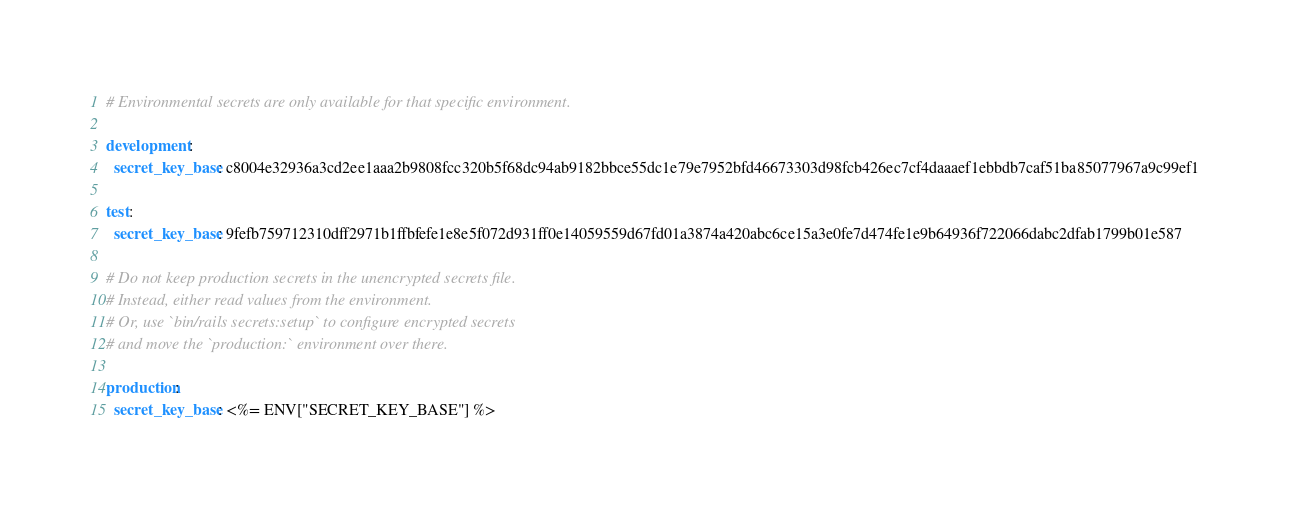Convert code to text. <code><loc_0><loc_0><loc_500><loc_500><_YAML_>
# Environmental secrets are only available for that specific environment.

development:
  secret_key_base: c8004e32936a3cd2ee1aaa2b9808fcc320b5f68dc94ab9182bbce55dc1e79e7952bfd46673303d98fcb426ec7cf4daaaef1ebbdb7caf51ba85077967a9c99ef1

test:
  secret_key_base: 9fefb759712310dff2971b1ffbfefe1e8e5f072d931ff0e14059559d67fd01a3874a420abc6ce15a3e0fe7d474fe1e9b64936f722066dabc2dfab1799b01e587

# Do not keep production secrets in the unencrypted secrets file.
# Instead, either read values from the environment.
# Or, use `bin/rails secrets:setup` to configure encrypted secrets
# and move the `production:` environment over there.

production:
  secret_key_base: <%= ENV["SECRET_KEY_BASE"] %>
</code> 